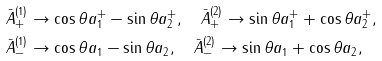<formula> <loc_0><loc_0><loc_500><loc_500>& \bar { A } _ { + } ^ { ( 1 ) } \to \cos \theta a _ { 1 } ^ { + } - \sin \theta a _ { 2 } ^ { + } , \quad \bar { A } _ { + } ^ { ( 2 ) } \to \sin \theta a _ { 1 } ^ { + } + \cos \theta a _ { 2 } ^ { + } , \\ & \bar { A } _ { - } ^ { ( 1 ) } \to \cos \theta a _ { 1 } - \sin \theta a _ { 2 } , \quad \bar { A } _ { - } ^ { ( 2 ) } \to \sin \theta a _ { 1 } + \cos \theta a _ { 2 } ,</formula> 